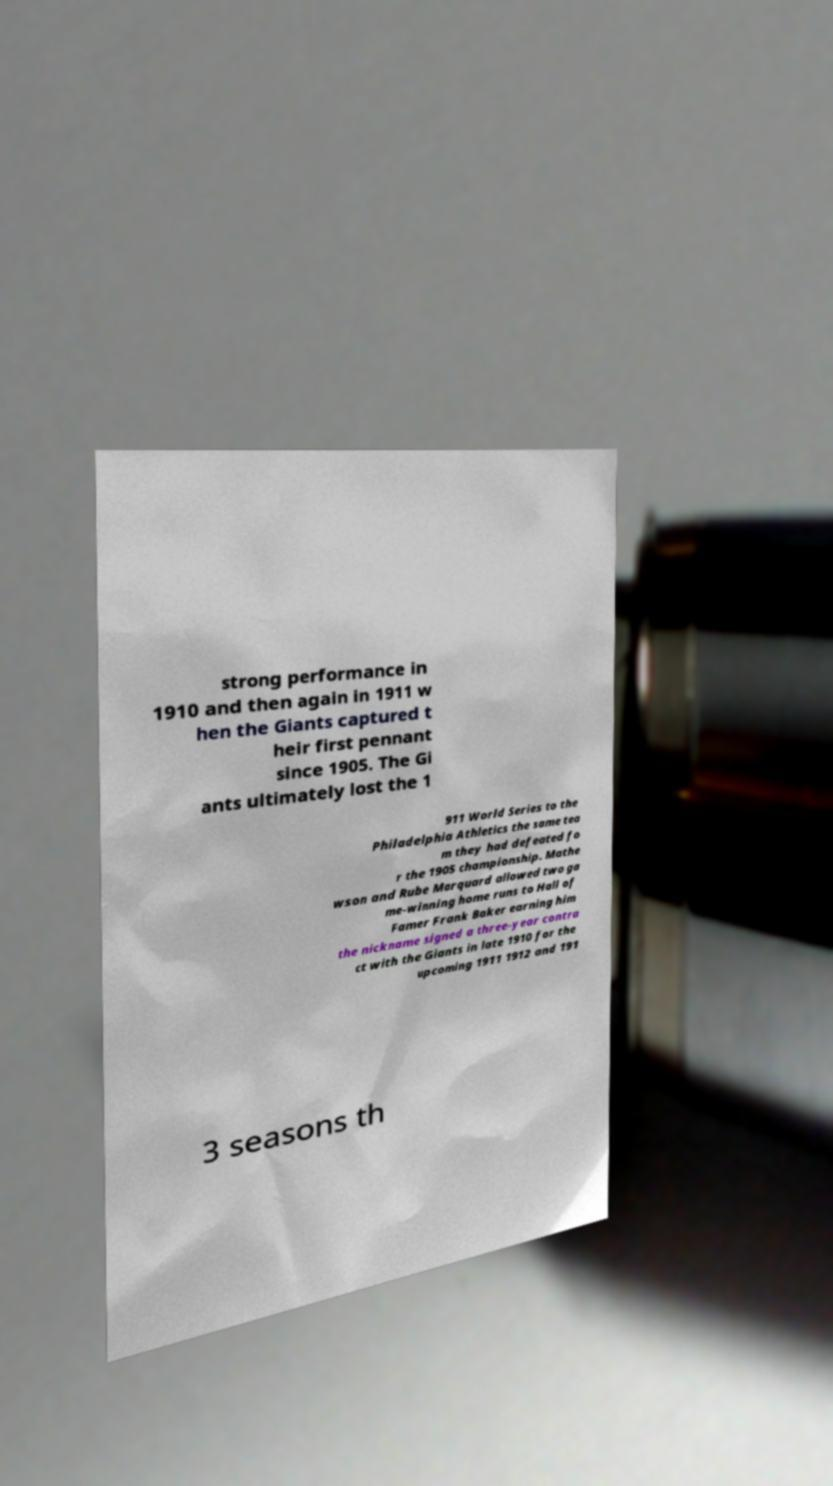Please read and relay the text visible in this image. What does it say? strong performance in 1910 and then again in 1911 w hen the Giants captured t heir first pennant since 1905. The Gi ants ultimately lost the 1 911 World Series to the Philadelphia Athletics the same tea m they had defeated fo r the 1905 championship. Mathe wson and Rube Marquard allowed two ga me-winning home runs to Hall of Famer Frank Baker earning him the nickname signed a three-year contra ct with the Giants in late 1910 for the upcoming 1911 1912 and 191 3 seasons th 